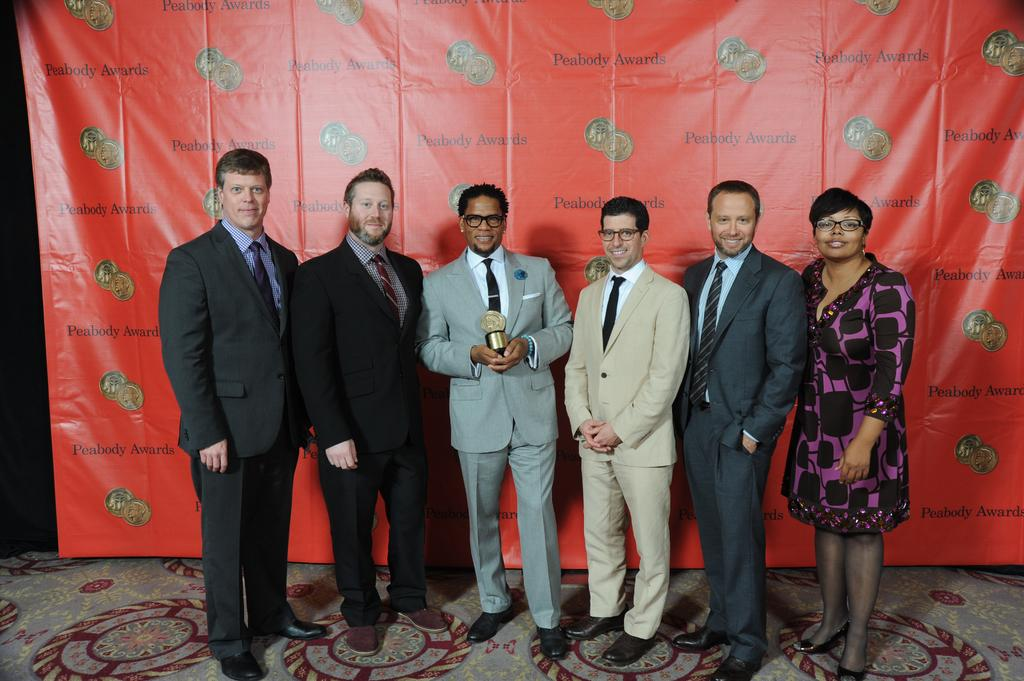How many people are present in the image? There are six persons standing in the image. What is the general mood of the people in the image? The persons are smiling, which suggests a positive or happy mood. What is the man in the middle holding? The man in the middle is holding a trophy.py. What can be seen in the background of the image? There is a banner visible in the background of the image. What type of van can be seen in the image? There is no van present in the image. What meal are the people sharing in the image? There is no meal visible in the image; it focuses on the people and the trophy. 